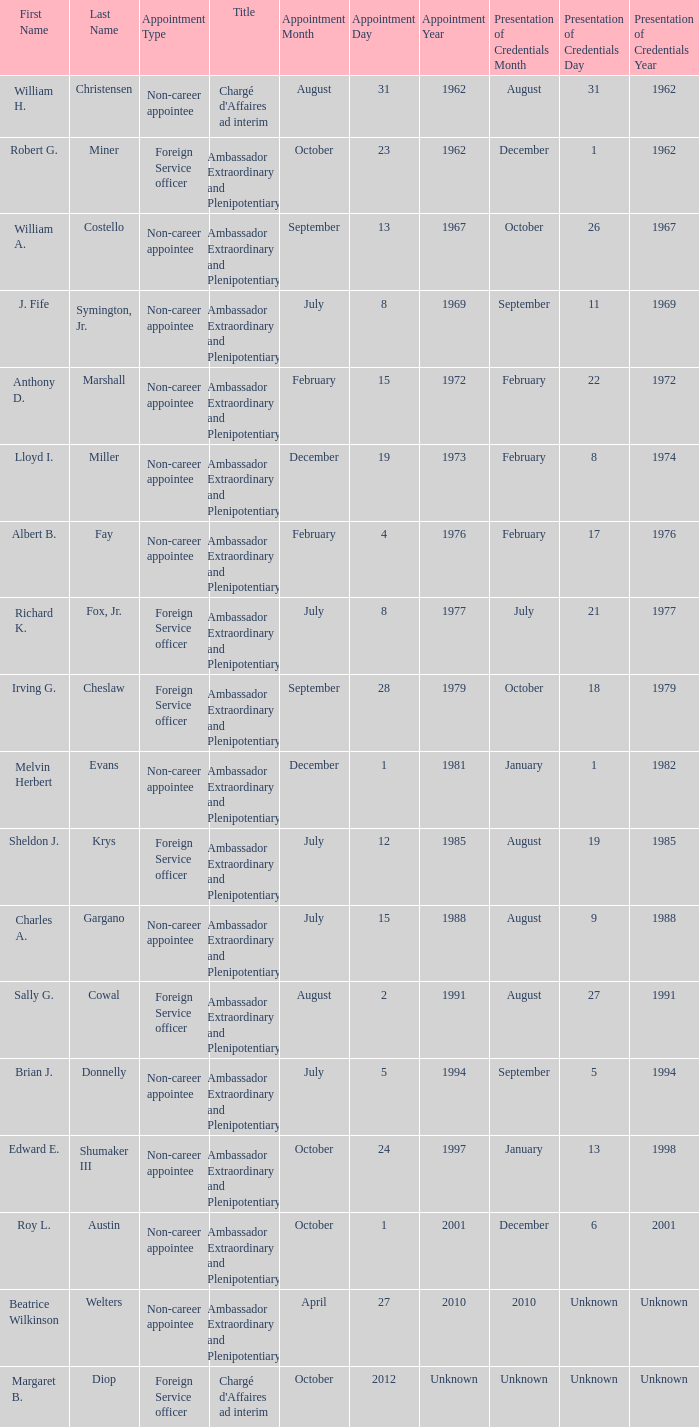What was Anthony D. Marshall's title? Ambassador Extraordinary and Plenipotentiary. 